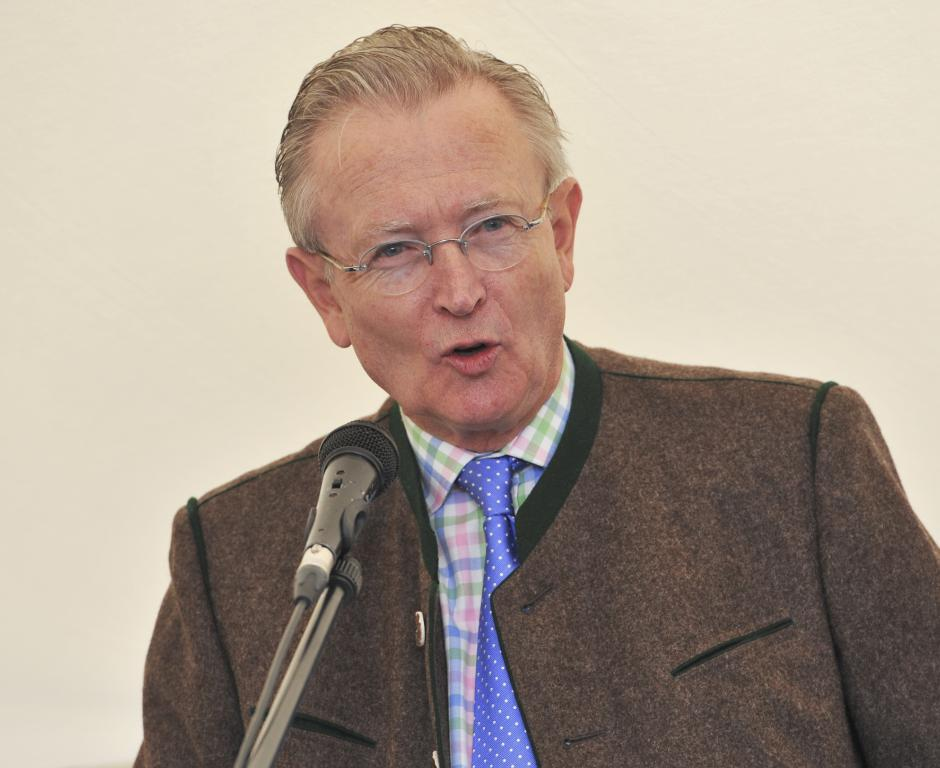Who is the main subject in the foreground of the image? There is a man in the foreground of the image. What is the man wearing in the image? The man is wearing a coat in the image. What object is the man standing in front of? The man is standing in front of a mic in the image. What color is the background of the image? The background of the image is cream-colored. What type of gold jewelry is the man wearing in the image? There is no gold jewelry visible on the man in the image. Can you see any turkeys in the background of the image? There are no turkeys present in the image; the background is cream-colored. 